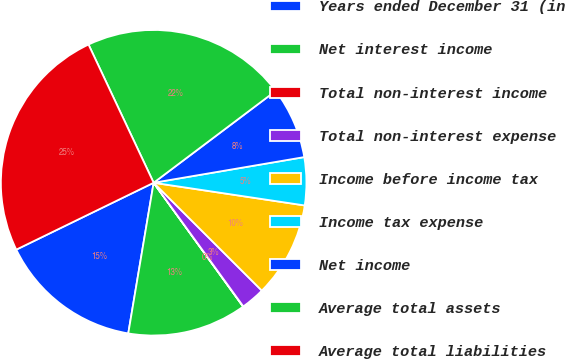Convert chart. <chart><loc_0><loc_0><loc_500><loc_500><pie_chart><fcel>Years ended December 31 (in<fcel>Net interest income<fcel>Total non-interest income<fcel>Total non-interest expense<fcel>Income before income tax<fcel>Income tax expense<fcel>Net income<fcel>Average total assets<fcel>Average total liabilities<nl><fcel>15.13%<fcel>12.61%<fcel>0.03%<fcel>2.54%<fcel>10.1%<fcel>5.06%<fcel>7.58%<fcel>21.74%<fcel>25.2%<nl></chart> 